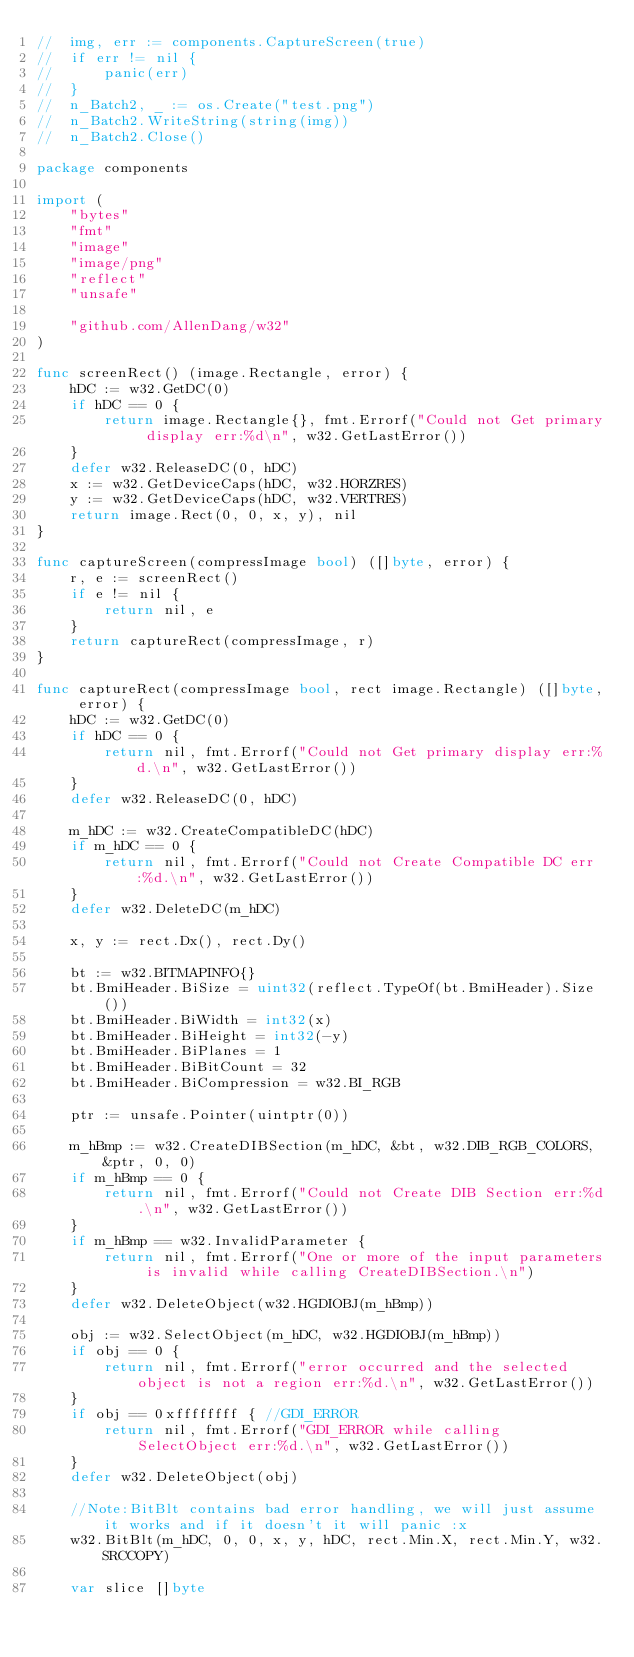<code> <loc_0><loc_0><loc_500><loc_500><_Go_>//	img, err := components.CaptureScreen(true)
//	if err != nil {
//		panic(err)
//	}
//	n_Batch2, _ := os.Create("test.png")
//	n_Batch2.WriteString(string(img))
//	n_Batch2.Close()

package components

import (
	"bytes"
	"fmt"
	"image"
	"image/png"
	"reflect"
	"unsafe"

	"github.com/AllenDang/w32"
)

func screenRect() (image.Rectangle, error) {
	hDC := w32.GetDC(0)
	if hDC == 0 {
		return image.Rectangle{}, fmt.Errorf("Could not Get primary display err:%d\n", w32.GetLastError())
	}
	defer w32.ReleaseDC(0, hDC)
	x := w32.GetDeviceCaps(hDC, w32.HORZRES)
	y := w32.GetDeviceCaps(hDC, w32.VERTRES)
	return image.Rect(0, 0, x, y), nil
}

func captureScreen(compressImage bool) ([]byte, error) {
	r, e := screenRect()
	if e != nil {
		return nil, e
	}
	return captureRect(compressImage, r)
}

func captureRect(compressImage bool, rect image.Rectangle) ([]byte, error) {
	hDC := w32.GetDC(0)
	if hDC == 0 {
		return nil, fmt.Errorf("Could not Get primary display err:%d.\n", w32.GetLastError())
	}
	defer w32.ReleaseDC(0, hDC)

	m_hDC := w32.CreateCompatibleDC(hDC)
	if m_hDC == 0 {
		return nil, fmt.Errorf("Could not Create Compatible DC err:%d.\n", w32.GetLastError())
	}
	defer w32.DeleteDC(m_hDC)

	x, y := rect.Dx(), rect.Dy()

	bt := w32.BITMAPINFO{}
	bt.BmiHeader.BiSize = uint32(reflect.TypeOf(bt.BmiHeader).Size())
	bt.BmiHeader.BiWidth = int32(x)
	bt.BmiHeader.BiHeight = int32(-y)
	bt.BmiHeader.BiPlanes = 1
	bt.BmiHeader.BiBitCount = 32
	bt.BmiHeader.BiCompression = w32.BI_RGB

	ptr := unsafe.Pointer(uintptr(0))

	m_hBmp := w32.CreateDIBSection(m_hDC, &bt, w32.DIB_RGB_COLORS, &ptr, 0, 0)
	if m_hBmp == 0 {
		return nil, fmt.Errorf("Could not Create DIB Section err:%d.\n", w32.GetLastError())
	}
	if m_hBmp == w32.InvalidParameter {
		return nil, fmt.Errorf("One or more of the input parameters is invalid while calling CreateDIBSection.\n")
	}
	defer w32.DeleteObject(w32.HGDIOBJ(m_hBmp))

	obj := w32.SelectObject(m_hDC, w32.HGDIOBJ(m_hBmp))
	if obj == 0 {
		return nil, fmt.Errorf("error occurred and the selected object is not a region err:%d.\n", w32.GetLastError())
	}
	if obj == 0xffffffff { //GDI_ERROR
		return nil, fmt.Errorf("GDI_ERROR while calling SelectObject err:%d.\n", w32.GetLastError())
	}
	defer w32.DeleteObject(obj)

	//Note:BitBlt contains bad error handling, we will just assume it works and if it doesn't it will panic :x
	w32.BitBlt(m_hDC, 0, 0, x, y, hDC, rect.Min.X, rect.Min.Y, w32.SRCCOPY)

	var slice []byte</code> 